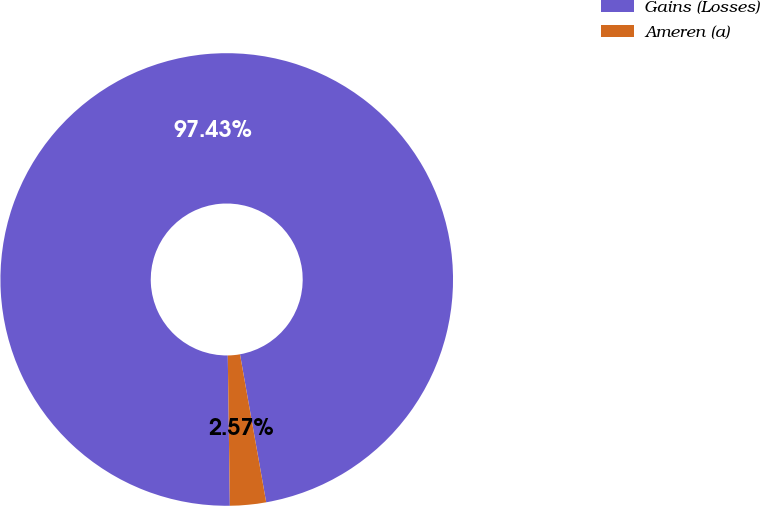<chart> <loc_0><loc_0><loc_500><loc_500><pie_chart><fcel>Gains (Losses)<fcel>Ameren (a)<nl><fcel>97.43%<fcel>2.57%<nl></chart> 